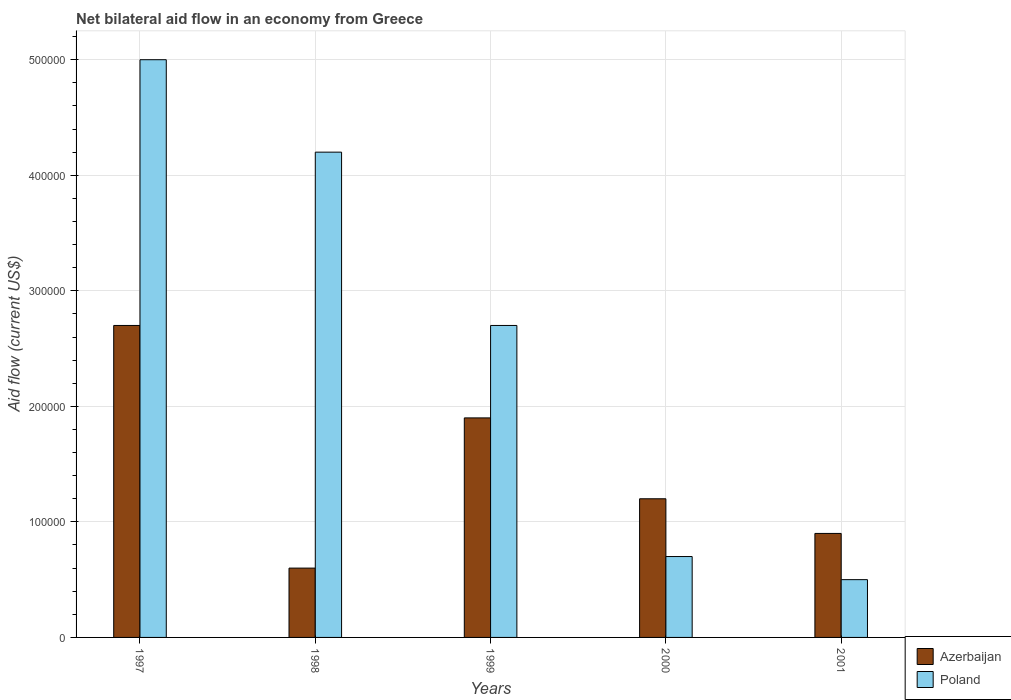How many different coloured bars are there?
Your answer should be compact. 2. Are the number of bars per tick equal to the number of legend labels?
Provide a short and direct response. Yes. Are the number of bars on each tick of the X-axis equal?
Offer a terse response. Yes. How many bars are there on the 1st tick from the right?
Give a very brief answer. 2. Across all years, what is the maximum net bilateral aid flow in Poland?
Your answer should be compact. 5.00e+05. What is the total net bilateral aid flow in Poland in the graph?
Give a very brief answer. 1.31e+06. What is the difference between the net bilateral aid flow in Poland in 1999 and that in 2000?
Provide a short and direct response. 2.00e+05. What is the average net bilateral aid flow in Poland per year?
Keep it short and to the point. 2.62e+05. In the year 1997, what is the difference between the net bilateral aid flow in Poland and net bilateral aid flow in Azerbaijan?
Your response must be concise. 2.30e+05. Is the net bilateral aid flow in Poland in 1997 less than that in 1999?
Offer a terse response. No. Is the difference between the net bilateral aid flow in Poland in 1998 and 2001 greater than the difference between the net bilateral aid flow in Azerbaijan in 1998 and 2001?
Your answer should be very brief. Yes. In how many years, is the net bilateral aid flow in Poland greater than the average net bilateral aid flow in Poland taken over all years?
Your answer should be compact. 3. What does the 1st bar from the left in 2001 represents?
Give a very brief answer. Azerbaijan. What does the 2nd bar from the right in 1999 represents?
Keep it short and to the point. Azerbaijan. Are all the bars in the graph horizontal?
Ensure brevity in your answer.  No. How many years are there in the graph?
Provide a short and direct response. 5. What is the difference between two consecutive major ticks on the Y-axis?
Offer a very short reply. 1.00e+05. Does the graph contain any zero values?
Ensure brevity in your answer.  No. What is the title of the graph?
Give a very brief answer. Net bilateral aid flow in an economy from Greece. Does "Mozambique" appear as one of the legend labels in the graph?
Your answer should be compact. No. What is the Aid flow (current US$) in Azerbaijan in 1997?
Provide a short and direct response. 2.70e+05. What is the Aid flow (current US$) in Poland in 1997?
Give a very brief answer. 5.00e+05. What is the Aid flow (current US$) in Poland in 1998?
Your answer should be compact. 4.20e+05. What is the Aid flow (current US$) in Poland in 1999?
Your answer should be compact. 2.70e+05. Across all years, what is the minimum Aid flow (current US$) of Poland?
Your answer should be compact. 5.00e+04. What is the total Aid flow (current US$) of Azerbaijan in the graph?
Give a very brief answer. 7.30e+05. What is the total Aid flow (current US$) of Poland in the graph?
Provide a succinct answer. 1.31e+06. What is the difference between the Aid flow (current US$) of Poland in 1997 and that in 1998?
Offer a very short reply. 8.00e+04. What is the difference between the Aid flow (current US$) in Azerbaijan in 1997 and that in 1999?
Provide a succinct answer. 8.00e+04. What is the difference between the Aid flow (current US$) in Azerbaijan in 1997 and that in 2000?
Make the answer very short. 1.50e+05. What is the difference between the Aid flow (current US$) in Azerbaijan in 1997 and that in 2001?
Provide a short and direct response. 1.80e+05. What is the difference between the Aid flow (current US$) of Azerbaijan in 1998 and that in 1999?
Keep it short and to the point. -1.30e+05. What is the difference between the Aid flow (current US$) in Poland in 1998 and that in 1999?
Your answer should be compact. 1.50e+05. What is the difference between the Aid flow (current US$) of Poland in 1998 and that in 2001?
Your answer should be very brief. 3.70e+05. What is the difference between the Aid flow (current US$) of Azerbaijan in 1999 and that in 2001?
Offer a very short reply. 1.00e+05. What is the difference between the Aid flow (current US$) in Poland in 2000 and that in 2001?
Give a very brief answer. 2.00e+04. What is the difference between the Aid flow (current US$) in Azerbaijan in 1997 and the Aid flow (current US$) in Poland in 1999?
Give a very brief answer. 0. What is the difference between the Aid flow (current US$) of Azerbaijan in 1997 and the Aid flow (current US$) of Poland in 2001?
Your answer should be compact. 2.20e+05. What is the difference between the Aid flow (current US$) in Azerbaijan in 1999 and the Aid flow (current US$) in Poland in 2000?
Offer a terse response. 1.20e+05. What is the difference between the Aid flow (current US$) of Azerbaijan in 1999 and the Aid flow (current US$) of Poland in 2001?
Offer a terse response. 1.40e+05. What is the difference between the Aid flow (current US$) in Azerbaijan in 2000 and the Aid flow (current US$) in Poland in 2001?
Ensure brevity in your answer.  7.00e+04. What is the average Aid flow (current US$) in Azerbaijan per year?
Make the answer very short. 1.46e+05. What is the average Aid flow (current US$) of Poland per year?
Keep it short and to the point. 2.62e+05. In the year 1997, what is the difference between the Aid flow (current US$) in Azerbaijan and Aid flow (current US$) in Poland?
Your answer should be compact. -2.30e+05. In the year 1998, what is the difference between the Aid flow (current US$) of Azerbaijan and Aid flow (current US$) of Poland?
Provide a succinct answer. -3.60e+05. In the year 1999, what is the difference between the Aid flow (current US$) of Azerbaijan and Aid flow (current US$) of Poland?
Give a very brief answer. -8.00e+04. In the year 2000, what is the difference between the Aid flow (current US$) of Azerbaijan and Aid flow (current US$) of Poland?
Your answer should be compact. 5.00e+04. In the year 2001, what is the difference between the Aid flow (current US$) of Azerbaijan and Aid flow (current US$) of Poland?
Ensure brevity in your answer.  4.00e+04. What is the ratio of the Aid flow (current US$) in Azerbaijan in 1997 to that in 1998?
Provide a succinct answer. 4.5. What is the ratio of the Aid flow (current US$) in Poland in 1997 to that in 1998?
Make the answer very short. 1.19. What is the ratio of the Aid flow (current US$) of Azerbaijan in 1997 to that in 1999?
Make the answer very short. 1.42. What is the ratio of the Aid flow (current US$) of Poland in 1997 to that in 1999?
Offer a terse response. 1.85. What is the ratio of the Aid flow (current US$) in Azerbaijan in 1997 to that in 2000?
Offer a very short reply. 2.25. What is the ratio of the Aid flow (current US$) in Poland in 1997 to that in 2000?
Keep it short and to the point. 7.14. What is the ratio of the Aid flow (current US$) of Azerbaijan in 1997 to that in 2001?
Your answer should be very brief. 3. What is the ratio of the Aid flow (current US$) of Poland in 1997 to that in 2001?
Provide a short and direct response. 10. What is the ratio of the Aid flow (current US$) of Azerbaijan in 1998 to that in 1999?
Ensure brevity in your answer.  0.32. What is the ratio of the Aid flow (current US$) in Poland in 1998 to that in 1999?
Give a very brief answer. 1.56. What is the ratio of the Aid flow (current US$) in Azerbaijan in 1998 to that in 2000?
Your answer should be very brief. 0.5. What is the ratio of the Aid flow (current US$) of Poland in 1998 to that in 2000?
Offer a terse response. 6. What is the ratio of the Aid flow (current US$) in Azerbaijan in 1999 to that in 2000?
Provide a succinct answer. 1.58. What is the ratio of the Aid flow (current US$) in Poland in 1999 to that in 2000?
Provide a short and direct response. 3.86. What is the ratio of the Aid flow (current US$) in Azerbaijan in 1999 to that in 2001?
Keep it short and to the point. 2.11. What is the ratio of the Aid flow (current US$) of Azerbaijan in 2000 to that in 2001?
Ensure brevity in your answer.  1.33. What is the ratio of the Aid flow (current US$) of Poland in 2000 to that in 2001?
Offer a terse response. 1.4. What is the difference between the highest and the second highest Aid flow (current US$) in Poland?
Make the answer very short. 8.00e+04. What is the difference between the highest and the lowest Aid flow (current US$) of Azerbaijan?
Your response must be concise. 2.10e+05. 